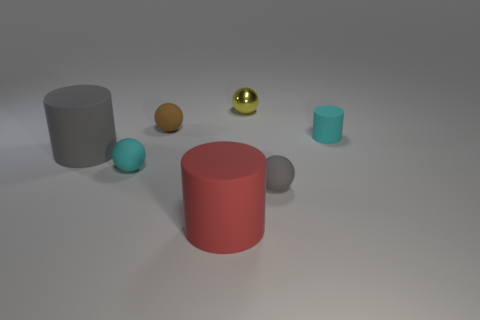What could be the possible material of the cyan cylinder? The material of the cyan cylinder appears to be a form of matte plastic due to its solid color and lack of significant reflectivity. The surface does not show traces of glossiness or specular highlights, which suggests it does not have a metallic or rubbery sheen. Its appearance is consistent with the look of a typical matte finish one might find on household plastic objects that are designed to diffuse light and conceal fingerprints or smudges. 